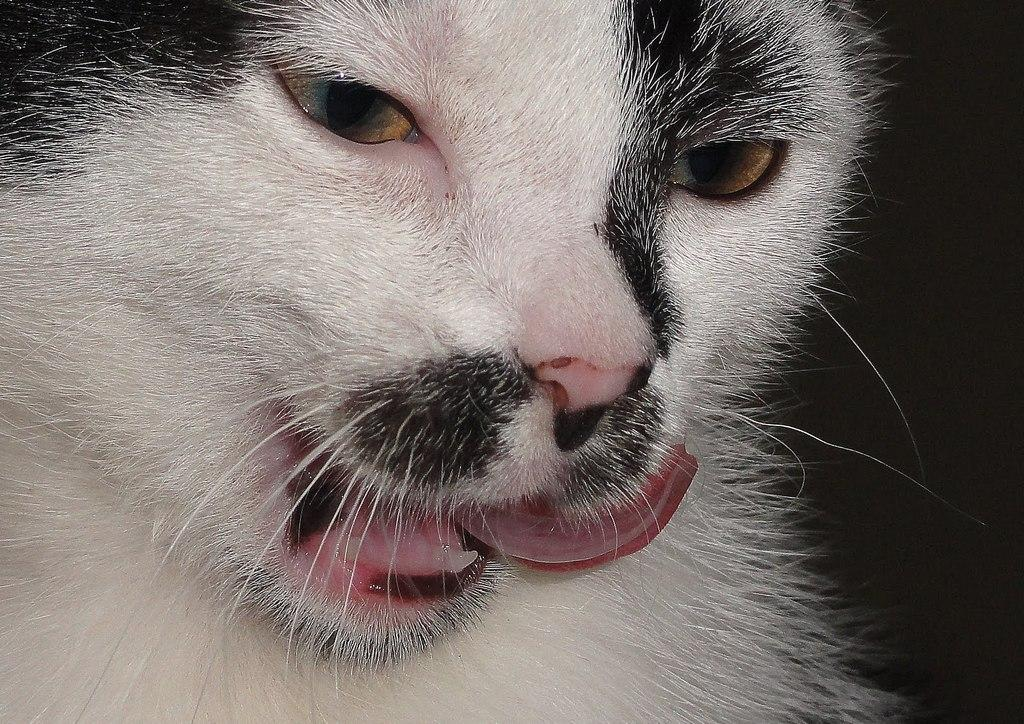What type of animal is in the image? There is a cat in the image. What color scheme is used for the cat? The cat is in black and white. What can be observed about the background of the image? The background of the image is dark. How many cars can be seen in the image? There are no cars present in the image; it features a black and white cat with a dark background. What type of steam is visible in the image? There is no steam present in the image. 